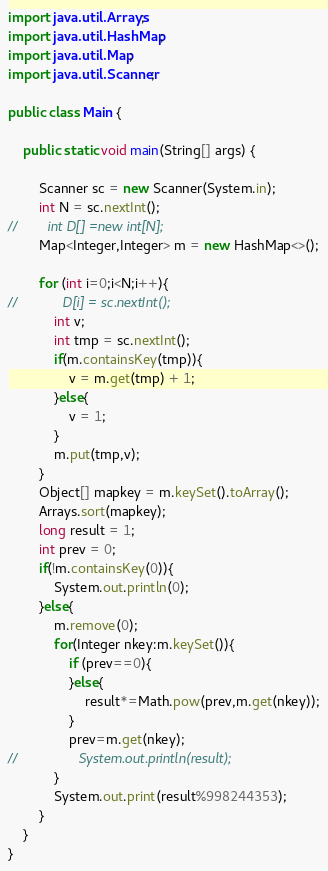Convert code to text. <code><loc_0><loc_0><loc_500><loc_500><_Java_>import java.util.Arrays;
import java.util.HashMap;
import java.util.Map;
import java.util.Scanner;

public class Main {

    public static void main(String[] args) {

        Scanner sc = new Scanner(System.in);
        int N = sc.nextInt();
//        int D[] =new int[N];
        Map<Integer,Integer> m = new HashMap<>();

        for (int i=0;i<N;i++){
//            D[i] = sc.nextInt();
            int v;
            int tmp = sc.nextInt();
            if(m.containsKey(tmp)){
                v = m.get(tmp) + 1;
            }else{
                v = 1;
            }
            m.put(tmp,v);
        }
        Object[] mapkey = m.keySet().toArray();
        Arrays.sort(mapkey);
        long result = 1;
        int prev = 0;
        if(!m.containsKey(0)){
            System.out.println(0);
        }else{
            m.remove(0);
            for(Integer nkey:m.keySet()){
                if (prev==0){
                }else{
                    result*=Math.pow(prev,m.get(nkey));
                }
                prev=m.get(nkey);
//                System.out.println(result);
            }
            System.out.print(result%998244353);
        }
    }
}
</code> 